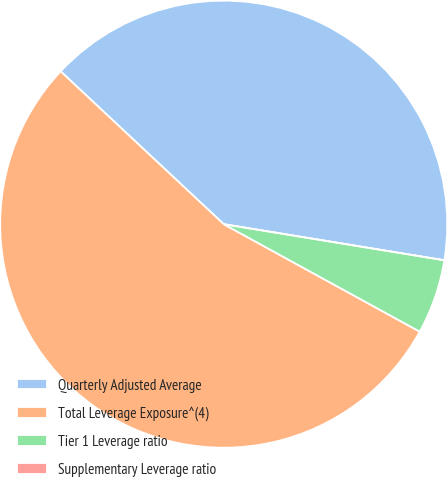<chart> <loc_0><loc_0><loc_500><loc_500><pie_chart><fcel>Quarterly Adjusted Average<fcel>Total Leverage Exposure^(4)<fcel>Tier 1 Leverage ratio<fcel>Supplementary Leverage ratio<nl><fcel>40.6%<fcel>54.0%<fcel>5.4%<fcel>0.0%<nl></chart> 